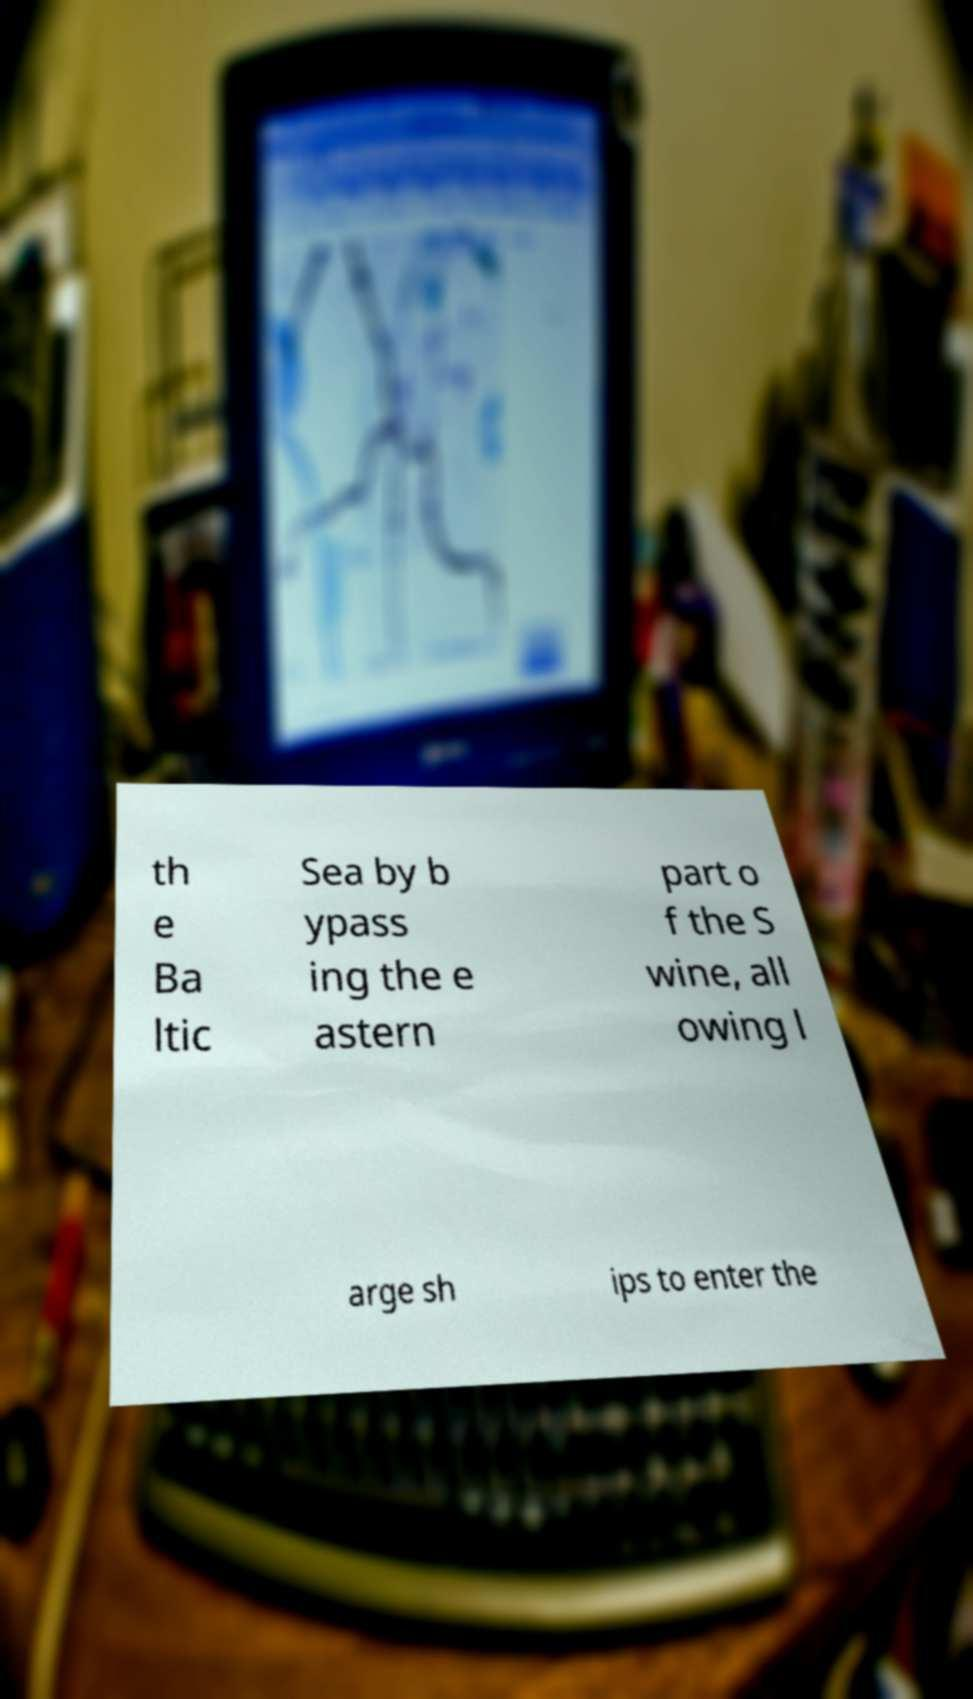Could you extract and type out the text from this image? th e Ba ltic Sea by b ypass ing the e astern part o f the S wine, all owing l arge sh ips to enter the 